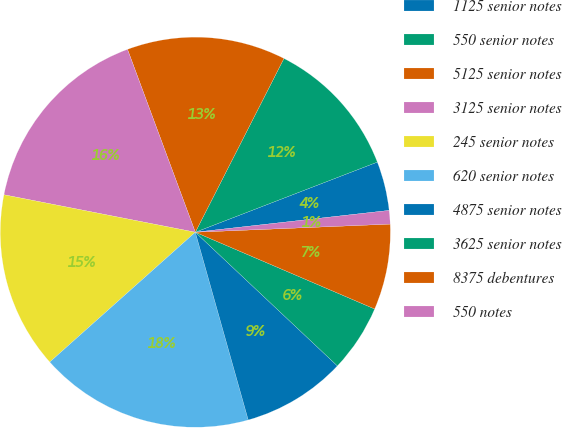Convert chart to OTSL. <chart><loc_0><loc_0><loc_500><loc_500><pie_chart><fcel>1125 senior notes<fcel>550 senior notes<fcel>5125 senior notes<fcel>3125 senior notes<fcel>245 senior notes<fcel>620 senior notes<fcel>4875 senior notes<fcel>3625 senior notes<fcel>8375 debentures<fcel>550 notes<nl><fcel>4.07%<fcel>11.64%<fcel>13.16%<fcel>16.27%<fcel>14.67%<fcel>17.78%<fcel>8.61%<fcel>5.58%<fcel>7.1%<fcel>1.12%<nl></chart> 